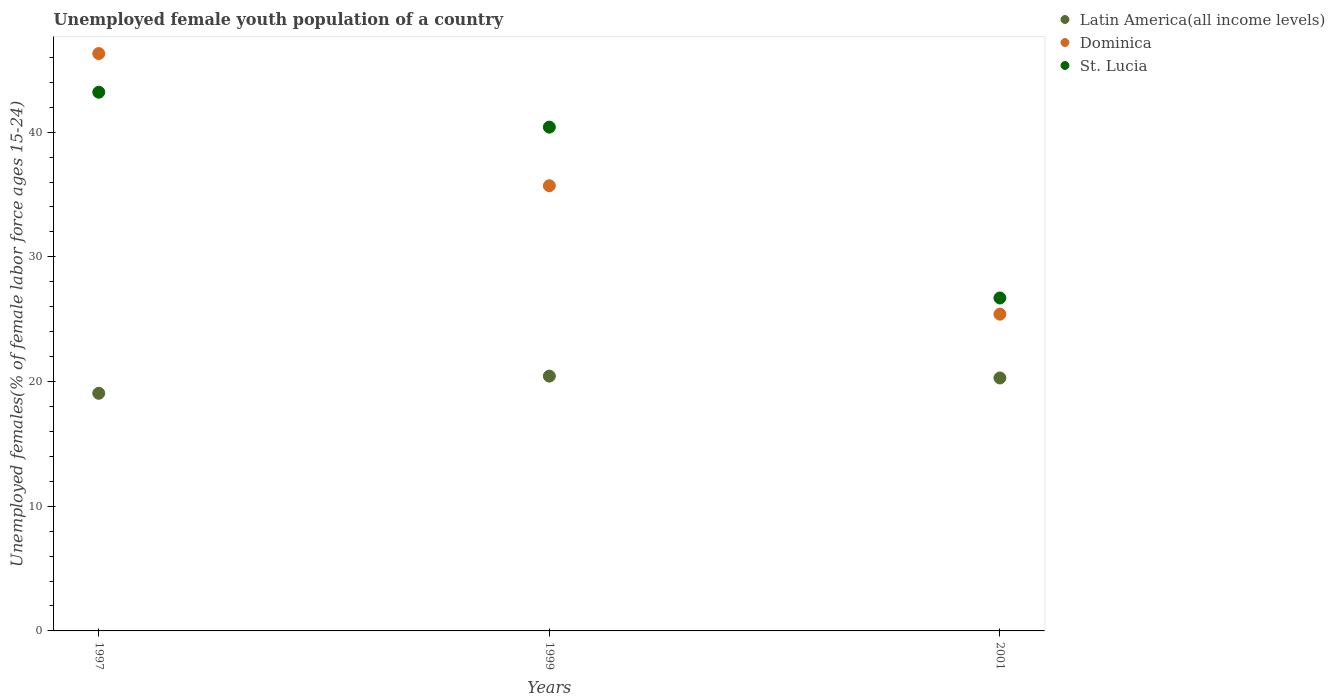What is the percentage of unemployed female youth population in Latin America(all income levels) in 1997?
Offer a very short reply. 19.06. Across all years, what is the maximum percentage of unemployed female youth population in Latin America(all income levels)?
Offer a terse response. 20.43. Across all years, what is the minimum percentage of unemployed female youth population in St. Lucia?
Give a very brief answer. 26.7. In which year was the percentage of unemployed female youth population in Dominica minimum?
Your response must be concise. 2001. What is the total percentage of unemployed female youth population in Dominica in the graph?
Provide a short and direct response. 107.4. What is the difference between the percentage of unemployed female youth population in Latin America(all income levels) in 1999 and that in 2001?
Provide a short and direct response. 0.15. What is the difference between the percentage of unemployed female youth population in St. Lucia in 1999 and the percentage of unemployed female youth population in Latin America(all income levels) in 2001?
Your response must be concise. 20.11. What is the average percentage of unemployed female youth population in Dominica per year?
Your answer should be very brief. 35.8. In the year 1997, what is the difference between the percentage of unemployed female youth population in Latin America(all income levels) and percentage of unemployed female youth population in St. Lucia?
Keep it short and to the point. -24.14. In how many years, is the percentage of unemployed female youth population in Dominica greater than 44 %?
Provide a short and direct response. 1. What is the ratio of the percentage of unemployed female youth population in St. Lucia in 1999 to that in 2001?
Offer a very short reply. 1.51. Is the percentage of unemployed female youth population in Latin America(all income levels) in 1997 less than that in 2001?
Keep it short and to the point. Yes. What is the difference between the highest and the second highest percentage of unemployed female youth population in Dominica?
Keep it short and to the point. 10.6. What is the difference between the highest and the lowest percentage of unemployed female youth population in Latin America(all income levels)?
Your answer should be compact. 1.38. Is the sum of the percentage of unemployed female youth population in Latin America(all income levels) in 1997 and 1999 greater than the maximum percentage of unemployed female youth population in St. Lucia across all years?
Ensure brevity in your answer.  No. Does the percentage of unemployed female youth population in Latin America(all income levels) monotonically increase over the years?
Your answer should be compact. No. What is the difference between two consecutive major ticks on the Y-axis?
Keep it short and to the point. 10. Are the values on the major ticks of Y-axis written in scientific E-notation?
Offer a terse response. No. How many legend labels are there?
Give a very brief answer. 3. What is the title of the graph?
Provide a short and direct response. Unemployed female youth population of a country. What is the label or title of the X-axis?
Make the answer very short. Years. What is the label or title of the Y-axis?
Provide a short and direct response. Unemployed females(% of female labor force ages 15-24). What is the Unemployed females(% of female labor force ages 15-24) of Latin America(all income levels) in 1997?
Your answer should be very brief. 19.06. What is the Unemployed females(% of female labor force ages 15-24) of Dominica in 1997?
Your answer should be very brief. 46.3. What is the Unemployed females(% of female labor force ages 15-24) of St. Lucia in 1997?
Make the answer very short. 43.2. What is the Unemployed females(% of female labor force ages 15-24) in Latin America(all income levels) in 1999?
Your answer should be compact. 20.43. What is the Unemployed females(% of female labor force ages 15-24) of Dominica in 1999?
Your answer should be compact. 35.7. What is the Unemployed females(% of female labor force ages 15-24) of St. Lucia in 1999?
Offer a very short reply. 40.4. What is the Unemployed females(% of female labor force ages 15-24) of Latin America(all income levels) in 2001?
Offer a terse response. 20.29. What is the Unemployed females(% of female labor force ages 15-24) in Dominica in 2001?
Offer a terse response. 25.4. What is the Unemployed females(% of female labor force ages 15-24) of St. Lucia in 2001?
Make the answer very short. 26.7. Across all years, what is the maximum Unemployed females(% of female labor force ages 15-24) of Latin America(all income levels)?
Offer a very short reply. 20.43. Across all years, what is the maximum Unemployed females(% of female labor force ages 15-24) of Dominica?
Make the answer very short. 46.3. Across all years, what is the maximum Unemployed females(% of female labor force ages 15-24) of St. Lucia?
Ensure brevity in your answer.  43.2. Across all years, what is the minimum Unemployed females(% of female labor force ages 15-24) of Latin America(all income levels)?
Provide a succinct answer. 19.06. Across all years, what is the minimum Unemployed females(% of female labor force ages 15-24) in Dominica?
Make the answer very short. 25.4. Across all years, what is the minimum Unemployed females(% of female labor force ages 15-24) of St. Lucia?
Provide a short and direct response. 26.7. What is the total Unemployed females(% of female labor force ages 15-24) in Latin America(all income levels) in the graph?
Your answer should be very brief. 59.78. What is the total Unemployed females(% of female labor force ages 15-24) in Dominica in the graph?
Your response must be concise. 107.4. What is the total Unemployed females(% of female labor force ages 15-24) of St. Lucia in the graph?
Keep it short and to the point. 110.3. What is the difference between the Unemployed females(% of female labor force ages 15-24) of Latin America(all income levels) in 1997 and that in 1999?
Your answer should be very brief. -1.38. What is the difference between the Unemployed females(% of female labor force ages 15-24) of Dominica in 1997 and that in 1999?
Your answer should be very brief. 10.6. What is the difference between the Unemployed females(% of female labor force ages 15-24) of Latin America(all income levels) in 1997 and that in 2001?
Give a very brief answer. -1.23. What is the difference between the Unemployed females(% of female labor force ages 15-24) in Dominica in 1997 and that in 2001?
Offer a terse response. 20.9. What is the difference between the Unemployed females(% of female labor force ages 15-24) in Latin America(all income levels) in 1999 and that in 2001?
Your response must be concise. 0.15. What is the difference between the Unemployed females(% of female labor force ages 15-24) in Dominica in 1999 and that in 2001?
Your answer should be compact. 10.3. What is the difference between the Unemployed females(% of female labor force ages 15-24) of St. Lucia in 1999 and that in 2001?
Offer a terse response. 13.7. What is the difference between the Unemployed females(% of female labor force ages 15-24) in Latin America(all income levels) in 1997 and the Unemployed females(% of female labor force ages 15-24) in Dominica in 1999?
Give a very brief answer. -16.64. What is the difference between the Unemployed females(% of female labor force ages 15-24) of Latin America(all income levels) in 1997 and the Unemployed females(% of female labor force ages 15-24) of St. Lucia in 1999?
Keep it short and to the point. -21.34. What is the difference between the Unemployed females(% of female labor force ages 15-24) in Dominica in 1997 and the Unemployed females(% of female labor force ages 15-24) in St. Lucia in 1999?
Offer a terse response. 5.9. What is the difference between the Unemployed females(% of female labor force ages 15-24) of Latin America(all income levels) in 1997 and the Unemployed females(% of female labor force ages 15-24) of Dominica in 2001?
Your response must be concise. -6.34. What is the difference between the Unemployed females(% of female labor force ages 15-24) in Latin America(all income levels) in 1997 and the Unemployed females(% of female labor force ages 15-24) in St. Lucia in 2001?
Your response must be concise. -7.64. What is the difference between the Unemployed females(% of female labor force ages 15-24) in Dominica in 1997 and the Unemployed females(% of female labor force ages 15-24) in St. Lucia in 2001?
Offer a very short reply. 19.6. What is the difference between the Unemployed females(% of female labor force ages 15-24) of Latin America(all income levels) in 1999 and the Unemployed females(% of female labor force ages 15-24) of Dominica in 2001?
Keep it short and to the point. -4.97. What is the difference between the Unemployed females(% of female labor force ages 15-24) in Latin America(all income levels) in 1999 and the Unemployed females(% of female labor force ages 15-24) in St. Lucia in 2001?
Your answer should be very brief. -6.27. What is the difference between the Unemployed females(% of female labor force ages 15-24) in Dominica in 1999 and the Unemployed females(% of female labor force ages 15-24) in St. Lucia in 2001?
Provide a short and direct response. 9. What is the average Unemployed females(% of female labor force ages 15-24) of Latin America(all income levels) per year?
Ensure brevity in your answer.  19.93. What is the average Unemployed females(% of female labor force ages 15-24) of Dominica per year?
Give a very brief answer. 35.8. What is the average Unemployed females(% of female labor force ages 15-24) in St. Lucia per year?
Provide a short and direct response. 36.77. In the year 1997, what is the difference between the Unemployed females(% of female labor force ages 15-24) of Latin America(all income levels) and Unemployed females(% of female labor force ages 15-24) of Dominica?
Your response must be concise. -27.24. In the year 1997, what is the difference between the Unemployed females(% of female labor force ages 15-24) of Latin America(all income levels) and Unemployed females(% of female labor force ages 15-24) of St. Lucia?
Give a very brief answer. -24.14. In the year 1997, what is the difference between the Unemployed females(% of female labor force ages 15-24) in Dominica and Unemployed females(% of female labor force ages 15-24) in St. Lucia?
Your answer should be compact. 3.1. In the year 1999, what is the difference between the Unemployed females(% of female labor force ages 15-24) in Latin America(all income levels) and Unemployed females(% of female labor force ages 15-24) in Dominica?
Offer a terse response. -15.27. In the year 1999, what is the difference between the Unemployed females(% of female labor force ages 15-24) of Latin America(all income levels) and Unemployed females(% of female labor force ages 15-24) of St. Lucia?
Keep it short and to the point. -19.97. In the year 2001, what is the difference between the Unemployed females(% of female labor force ages 15-24) in Latin America(all income levels) and Unemployed females(% of female labor force ages 15-24) in Dominica?
Your response must be concise. -5.11. In the year 2001, what is the difference between the Unemployed females(% of female labor force ages 15-24) in Latin America(all income levels) and Unemployed females(% of female labor force ages 15-24) in St. Lucia?
Your answer should be compact. -6.41. What is the ratio of the Unemployed females(% of female labor force ages 15-24) in Latin America(all income levels) in 1997 to that in 1999?
Your answer should be compact. 0.93. What is the ratio of the Unemployed females(% of female labor force ages 15-24) of Dominica in 1997 to that in 1999?
Ensure brevity in your answer.  1.3. What is the ratio of the Unemployed females(% of female labor force ages 15-24) of St. Lucia in 1997 to that in 1999?
Provide a succinct answer. 1.07. What is the ratio of the Unemployed females(% of female labor force ages 15-24) in Latin America(all income levels) in 1997 to that in 2001?
Ensure brevity in your answer.  0.94. What is the ratio of the Unemployed females(% of female labor force ages 15-24) in Dominica in 1997 to that in 2001?
Your response must be concise. 1.82. What is the ratio of the Unemployed females(% of female labor force ages 15-24) of St. Lucia in 1997 to that in 2001?
Offer a terse response. 1.62. What is the ratio of the Unemployed females(% of female labor force ages 15-24) in Latin America(all income levels) in 1999 to that in 2001?
Your answer should be compact. 1.01. What is the ratio of the Unemployed females(% of female labor force ages 15-24) in Dominica in 1999 to that in 2001?
Your answer should be very brief. 1.41. What is the ratio of the Unemployed females(% of female labor force ages 15-24) in St. Lucia in 1999 to that in 2001?
Keep it short and to the point. 1.51. What is the difference between the highest and the second highest Unemployed females(% of female labor force ages 15-24) of Latin America(all income levels)?
Provide a short and direct response. 0.15. What is the difference between the highest and the lowest Unemployed females(% of female labor force ages 15-24) in Latin America(all income levels)?
Offer a terse response. 1.38. What is the difference between the highest and the lowest Unemployed females(% of female labor force ages 15-24) of Dominica?
Provide a succinct answer. 20.9. What is the difference between the highest and the lowest Unemployed females(% of female labor force ages 15-24) of St. Lucia?
Ensure brevity in your answer.  16.5. 